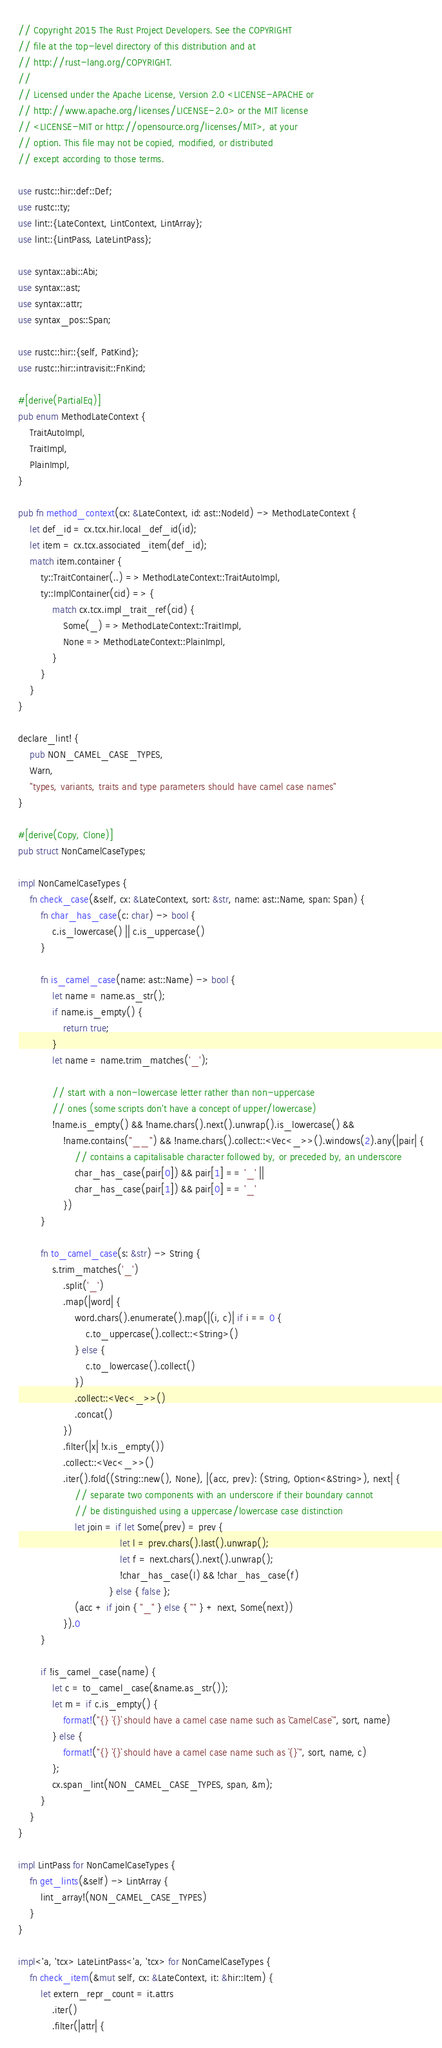<code> <loc_0><loc_0><loc_500><loc_500><_Rust_>// Copyright 2015 The Rust Project Developers. See the COPYRIGHT
// file at the top-level directory of this distribution and at
// http://rust-lang.org/COPYRIGHT.
//
// Licensed under the Apache License, Version 2.0 <LICENSE-APACHE or
// http://www.apache.org/licenses/LICENSE-2.0> or the MIT license
// <LICENSE-MIT or http://opensource.org/licenses/MIT>, at your
// option. This file may not be copied, modified, or distributed
// except according to those terms.

use rustc::hir::def::Def;
use rustc::ty;
use lint::{LateContext, LintContext, LintArray};
use lint::{LintPass, LateLintPass};

use syntax::abi::Abi;
use syntax::ast;
use syntax::attr;
use syntax_pos::Span;

use rustc::hir::{self, PatKind};
use rustc::hir::intravisit::FnKind;

#[derive(PartialEq)]
pub enum MethodLateContext {
    TraitAutoImpl,
    TraitImpl,
    PlainImpl,
}

pub fn method_context(cx: &LateContext, id: ast::NodeId) -> MethodLateContext {
    let def_id = cx.tcx.hir.local_def_id(id);
    let item = cx.tcx.associated_item(def_id);
    match item.container {
        ty::TraitContainer(..) => MethodLateContext::TraitAutoImpl,
        ty::ImplContainer(cid) => {
            match cx.tcx.impl_trait_ref(cid) {
                Some(_) => MethodLateContext::TraitImpl,
                None => MethodLateContext::PlainImpl,
            }
        }
    }
}

declare_lint! {
    pub NON_CAMEL_CASE_TYPES,
    Warn,
    "types, variants, traits and type parameters should have camel case names"
}

#[derive(Copy, Clone)]
pub struct NonCamelCaseTypes;

impl NonCamelCaseTypes {
    fn check_case(&self, cx: &LateContext, sort: &str, name: ast::Name, span: Span) {
        fn char_has_case(c: char) -> bool {
            c.is_lowercase() || c.is_uppercase()
        }

        fn is_camel_case(name: ast::Name) -> bool {
            let name = name.as_str();
            if name.is_empty() {
                return true;
            }
            let name = name.trim_matches('_');

            // start with a non-lowercase letter rather than non-uppercase
            // ones (some scripts don't have a concept of upper/lowercase)
            !name.is_empty() && !name.chars().next().unwrap().is_lowercase() &&
                !name.contains("__") && !name.chars().collect::<Vec<_>>().windows(2).any(|pair| {
                    // contains a capitalisable character followed by, or preceded by, an underscore
                    char_has_case(pair[0]) && pair[1] == '_' ||
                    char_has_case(pair[1]) && pair[0] == '_'
                })
        }

        fn to_camel_case(s: &str) -> String {
            s.trim_matches('_')
                .split('_')
                .map(|word| {
                    word.chars().enumerate().map(|(i, c)| if i == 0 {
                        c.to_uppercase().collect::<String>()
                    } else {
                        c.to_lowercase().collect()
                    })
                    .collect::<Vec<_>>()
                    .concat()
                })
                .filter(|x| !x.is_empty())
                .collect::<Vec<_>>()
                .iter().fold((String::new(), None), |(acc, prev): (String, Option<&String>), next| {
                    // separate two components with an underscore if their boundary cannot
                    // be distinguished using a uppercase/lowercase case distinction
                    let join = if let Some(prev) = prev {
                                    let l = prev.chars().last().unwrap();
                                    let f = next.chars().next().unwrap();
                                    !char_has_case(l) && !char_has_case(f)
                                } else { false };
                    (acc + if join { "_" } else { "" } + next, Some(next))
                }).0
        }

        if !is_camel_case(name) {
            let c = to_camel_case(&name.as_str());
            let m = if c.is_empty() {
                format!("{} `{}` should have a camel case name such as `CamelCase`", sort, name)
            } else {
                format!("{} `{}` should have a camel case name such as `{}`", sort, name, c)
            };
            cx.span_lint(NON_CAMEL_CASE_TYPES, span, &m);
        }
    }
}

impl LintPass for NonCamelCaseTypes {
    fn get_lints(&self) -> LintArray {
        lint_array!(NON_CAMEL_CASE_TYPES)
    }
}

impl<'a, 'tcx> LateLintPass<'a, 'tcx> for NonCamelCaseTypes {
    fn check_item(&mut self, cx: &LateContext, it: &hir::Item) {
        let extern_repr_count = it.attrs
            .iter()
            .filter(|attr| {</code> 